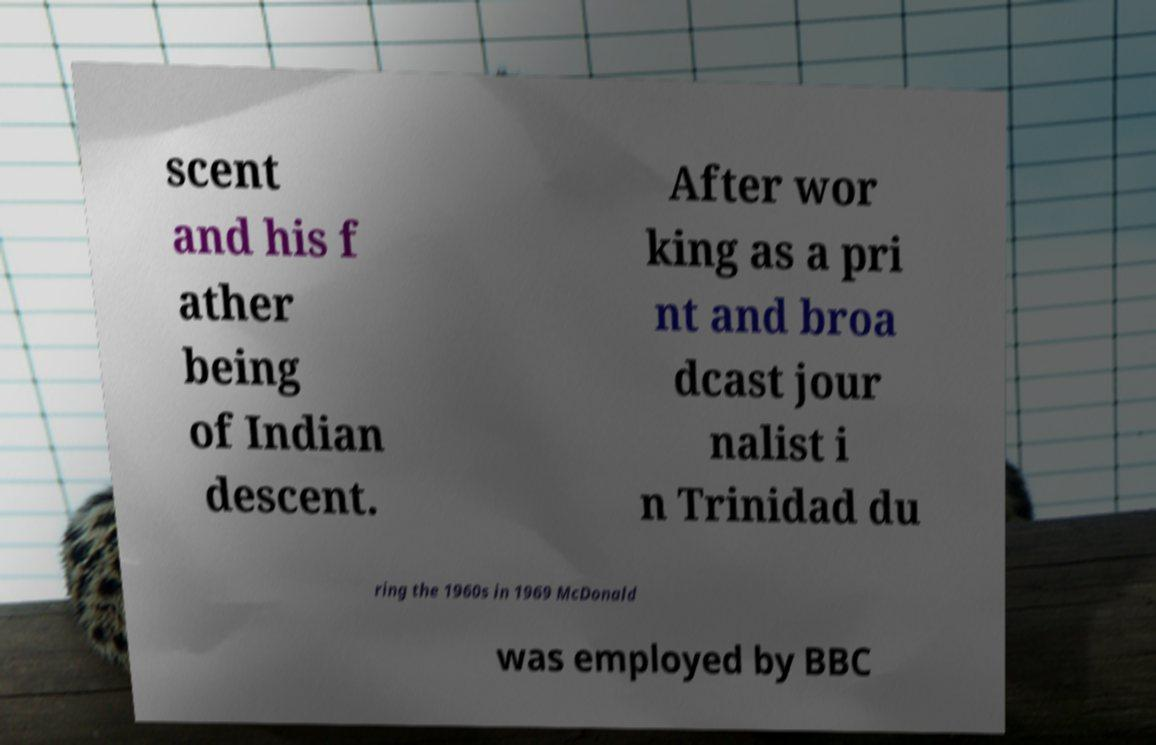For documentation purposes, I need the text within this image transcribed. Could you provide that? scent and his f ather being of Indian descent. After wor king as a pri nt and broa dcast jour nalist i n Trinidad du ring the 1960s in 1969 McDonald was employed by BBC 